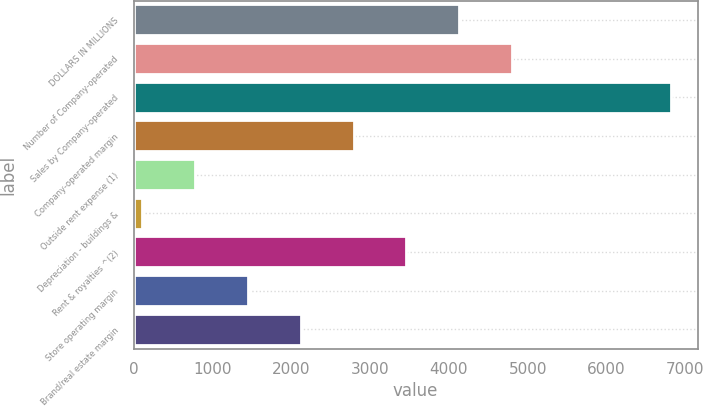Convert chart. <chart><loc_0><loc_0><loc_500><loc_500><bar_chart><fcel>DOLLARS IN MILLIONS<fcel>Number of Company-operated<fcel>Sales by Company-operated<fcel>Company-operated margin<fcel>Outside rent expense (1)<fcel>Depreciation - buildings &<fcel>Rent & royalties ^(2)<fcel>Store operating margin<fcel>Brand/real estate margin<nl><fcel>4133<fcel>4804<fcel>6817<fcel>2791<fcel>778<fcel>107<fcel>3462<fcel>1449<fcel>2120<nl></chart> 